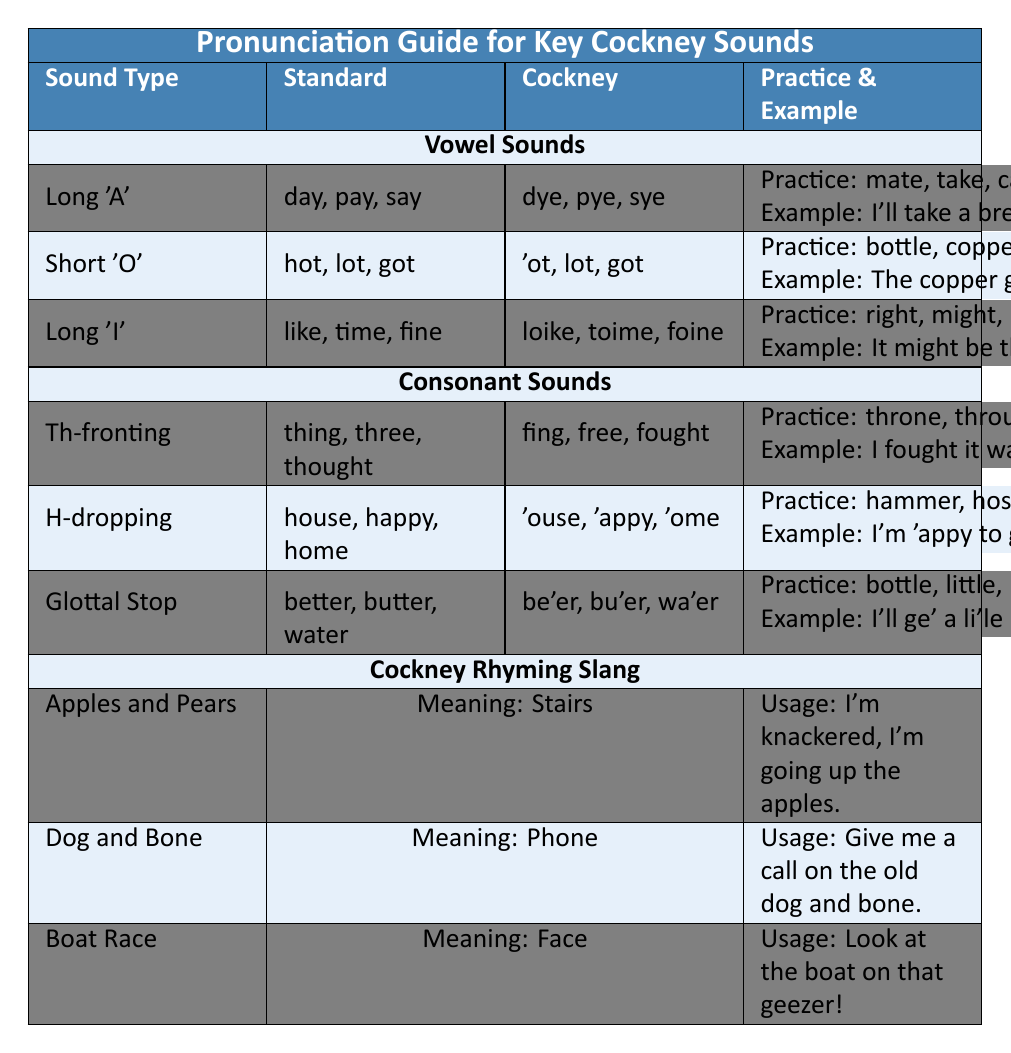What is the Cockney pronunciation for the word "take"? The table states that the Cockney pronunciation for "take" is "tike", as seen under the Long 'A' vowel sound section.
Answer: tike Which consonant sound has 'house' pronounced as 'ouse'? According to the table, the H-dropping consonant sound shows that 'house' is pronounced as 'ouse'.
Answer: H-dropping List one practice word for the Long 'I' vowel sound. The Long 'I' section cites "right" as one of the practice words, along with "might" and "height".
Answer: right Do Cockney speakers drop the 'h' in 'happy'? Yes, the H-dropping entry indicates that 'happy' is pronounced as 'appy in Cockney.
Answer: Yes What are the two example phrases provided for the 'Th-fronting' consonant sound? The table only provides one example for Th-fronting, which is "I fought it was free to go through," and does not list a second phrase.
Answer: One phrase is provided How does Cockney pronunciation change for the phrase "better"? In Cockney, "better" is pronounced as "be'er", according to the Glottal Stop section of the table.
Answer: be'er Which Cockney rhyming slang is used for 'stairs'? The phrase "Apples and Pears" is used for 'stairs', as noted in the Cockney Rhyming Slang section.
Answer: Apples and Pears What is the total number of practice words listed for each vowel sound? For Long 'A', there are 3 practice words; for Short 'O', there are also 3; and for Long 'I', there are 3, totaling 9 practice words.
Answer: 9 Are all practice words in the table 3 words each? Yes, each vowel sound listed in the table consistently has 3 practice words referenced.
Answer: Yes What is the usage example for the Cockney rhyming slang for 'phone'? The usage example for 'phone' is "Give me a call on the old dog and bone," found in the Dog and Bone entry.
Answer: Give me a call on the old dog and bone 